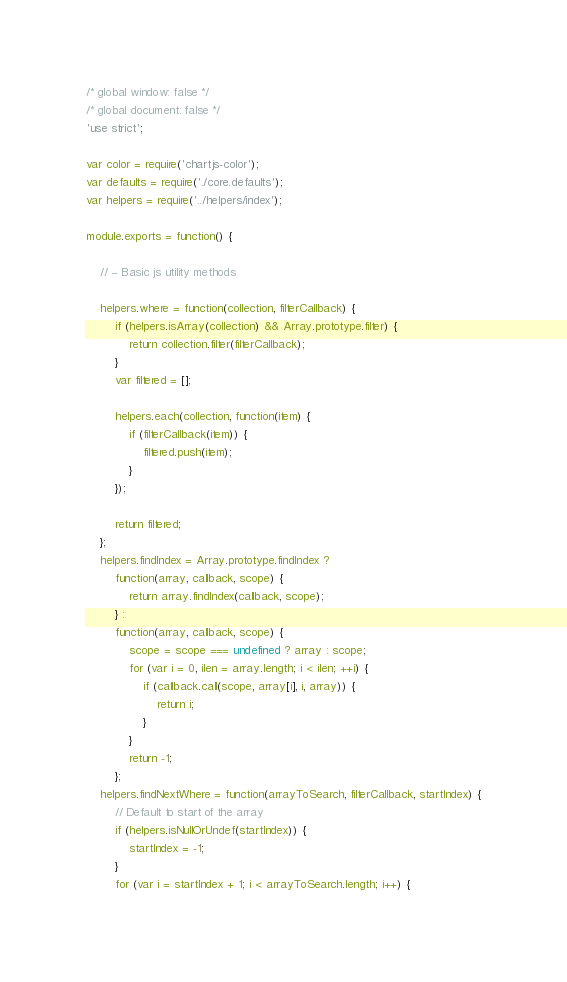Convert code to text. <code><loc_0><loc_0><loc_500><loc_500><_JavaScript_>/* global window: false */
/* global document: false */
'use strict';

var color = require('chartjs-color');
var defaults = require('./core.defaults');
var helpers = require('../helpers/index');

module.exports = function() {

	// -- Basic js utility methods

	helpers.where = function(collection, filterCallback) {
		if (helpers.isArray(collection) && Array.prototype.filter) {
			return collection.filter(filterCallback);
		}
		var filtered = [];

		helpers.each(collection, function(item) {
			if (filterCallback(item)) {
				filtered.push(item);
			}
		});

		return filtered;
	};
	helpers.findIndex = Array.prototype.findIndex ?
		function(array, callback, scope) {
			return array.findIndex(callback, scope);
		} :
		function(array, callback, scope) {
			scope = scope === undefined ? array : scope;
			for (var i = 0, ilen = array.length; i < ilen; ++i) {
				if (callback.call(scope, array[i], i, array)) {
					return i;
				}
			}
			return -1;
		};
	helpers.findNextWhere = function(arrayToSearch, filterCallback, startIndex) {
		// Default to start of the array
		if (helpers.isNullOrUndef(startIndex)) {
			startIndex = -1;
		}
		for (var i = startIndex + 1; i < arrayToSearch.length; i++) {</code> 